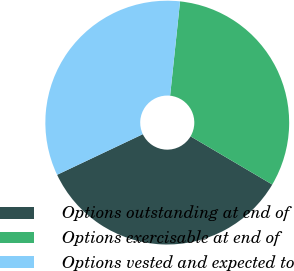Convert chart to OTSL. <chart><loc_0><loc_0><loc_500><loc_500><pie_chart><fcel>Options outstanding at end of<fcel>Options exercisable at end of<fcel>Options vested and expected to<nl><fcel>34.48%<fcel>31.81%<fcel>33.72%<nl></chart> 